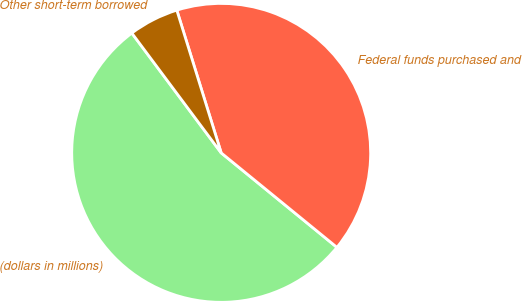Convert chart to OTSL. <chart><loc_0><loc_0><loc_500><loc_500><pie_chart><fcel>(dollars in millions)<fcel>Federal funds purchased and<fcel>Other short-term borrowed<nl><fcel>53.91%<fcel>40.7%<fcel>5.4%<nl></chart> 